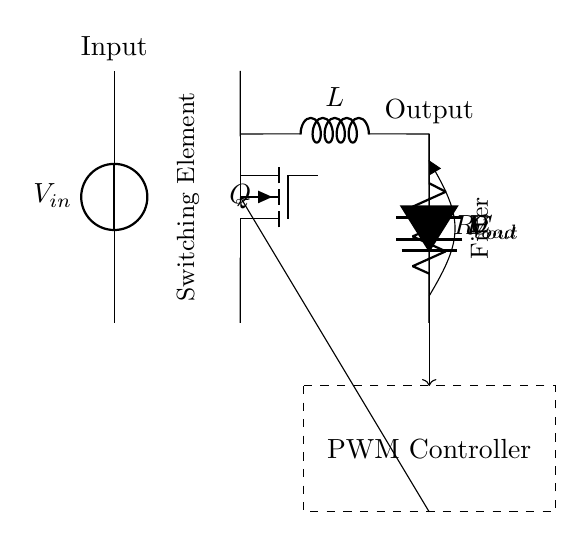What is the type of switching element used in this circuit? The symbol for the switching element in the circuit is labeled as "Q," which indicates that it's a MOSFET (specifically a N-channel MOSFET).
Answer: MOSFET What component is used to smooth the output voltage? In the circuit, the component labeled "C" represents a capacitor, which is used to filter and smooth the output voltage.
Answer: Capacitor How many main components are in this synchronous buck converter circuit? The diagram shows six key components: input voltage source, MOSFET, inductor, diode, capacitor, and load resistor, totaling six main components.
Answer: Six What is the role of the inductor in this circuit? The inductor, labeled as "L," stores energy during the ON phase of the switching MOSFET and releases it when the MOSFET is OFF, helping to maintain a steady output current.
Answer: Energy storage Which component provides feedback to the PWM controller? The feedback is provided by the output voltage, which is connected to the PWM controller via the arrowed line in the circuit, allowing the controller to adjust duty cycle accordingly.
Answer: Output voltage What is the function of the diode in this circuit? The diode, labeled "D," ensures current flows only in one direction to prevent backflow while the MOSFET is switching, and it operates in sync with the inductor to maintain output stability.
Answer: Prevent backflow What does "PWM" stand for, as indicated in the circuit diagram? In the context of this circuit, "PWM" stands for Pulse Width Modulation, which is a technique used by the controller to regulate the output voltage by varying the duty cycle.
Answer: Pulse Width Modulation 